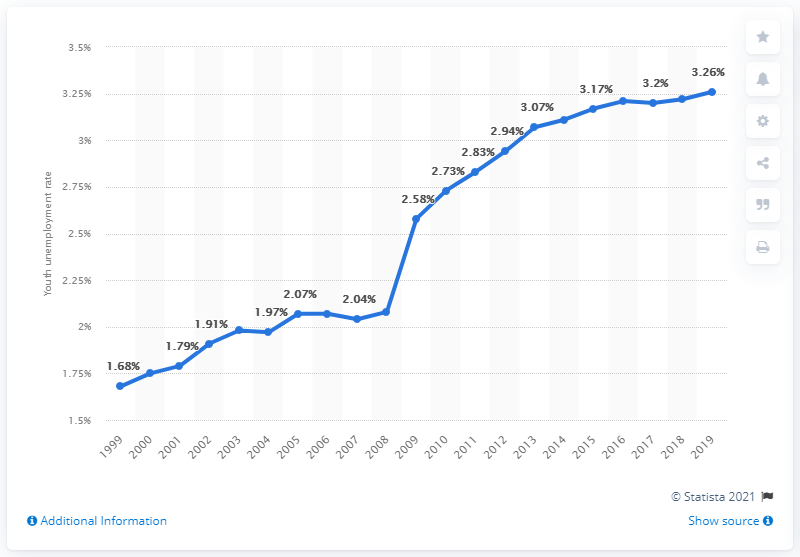Mention a couple of crucial points in this snapshot. The youth unemployment rate in Chad in 2019 was 3.26, according to recent data. 